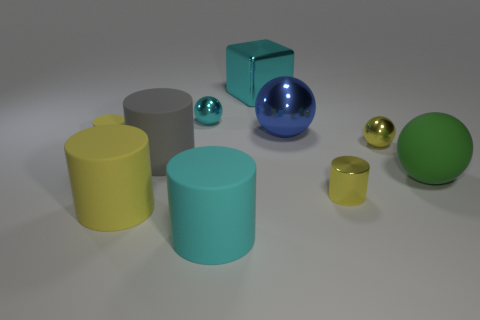What is the size of the other rubber thing that is the same shape as the tiny cyan thing?
Provide a short and direct response. Large. Is the number of tiny yellow matte cylinders that are right of the big yellow cylinder less than the number of large cyan rubber spheres?
Keep it short and to the point. No. What is the shape of the cyan metal thing that is to the right of the cyan rubber cylinder?
Ensure brevity in your answer.  Cube. There is a yellow ball; is its size the same as the cyan object in front of the green matte thing?
Your answer should be very brief. No. Is there a tiny gray ball made of the same material as the big yellow thing?
Offer a terse response. No. What number of blocks are either small yellow matte objects or large yellow matte objects?
Offer a very short reply. 0. There is a metallic object in front of the large green rubber object; are there any big matte things that are in front of it?
Keep it short and to the point. Yes. Is the number of purple cylinders less than the number of small spheres?
Keep it short and to the point. Yes. How many big blue things have the same shape as the tiny cyan shiny thing?
Your response must be concise. 1. How many yellow things are either metallic spheres or matte things?
Keep it short and to the point. 3. 